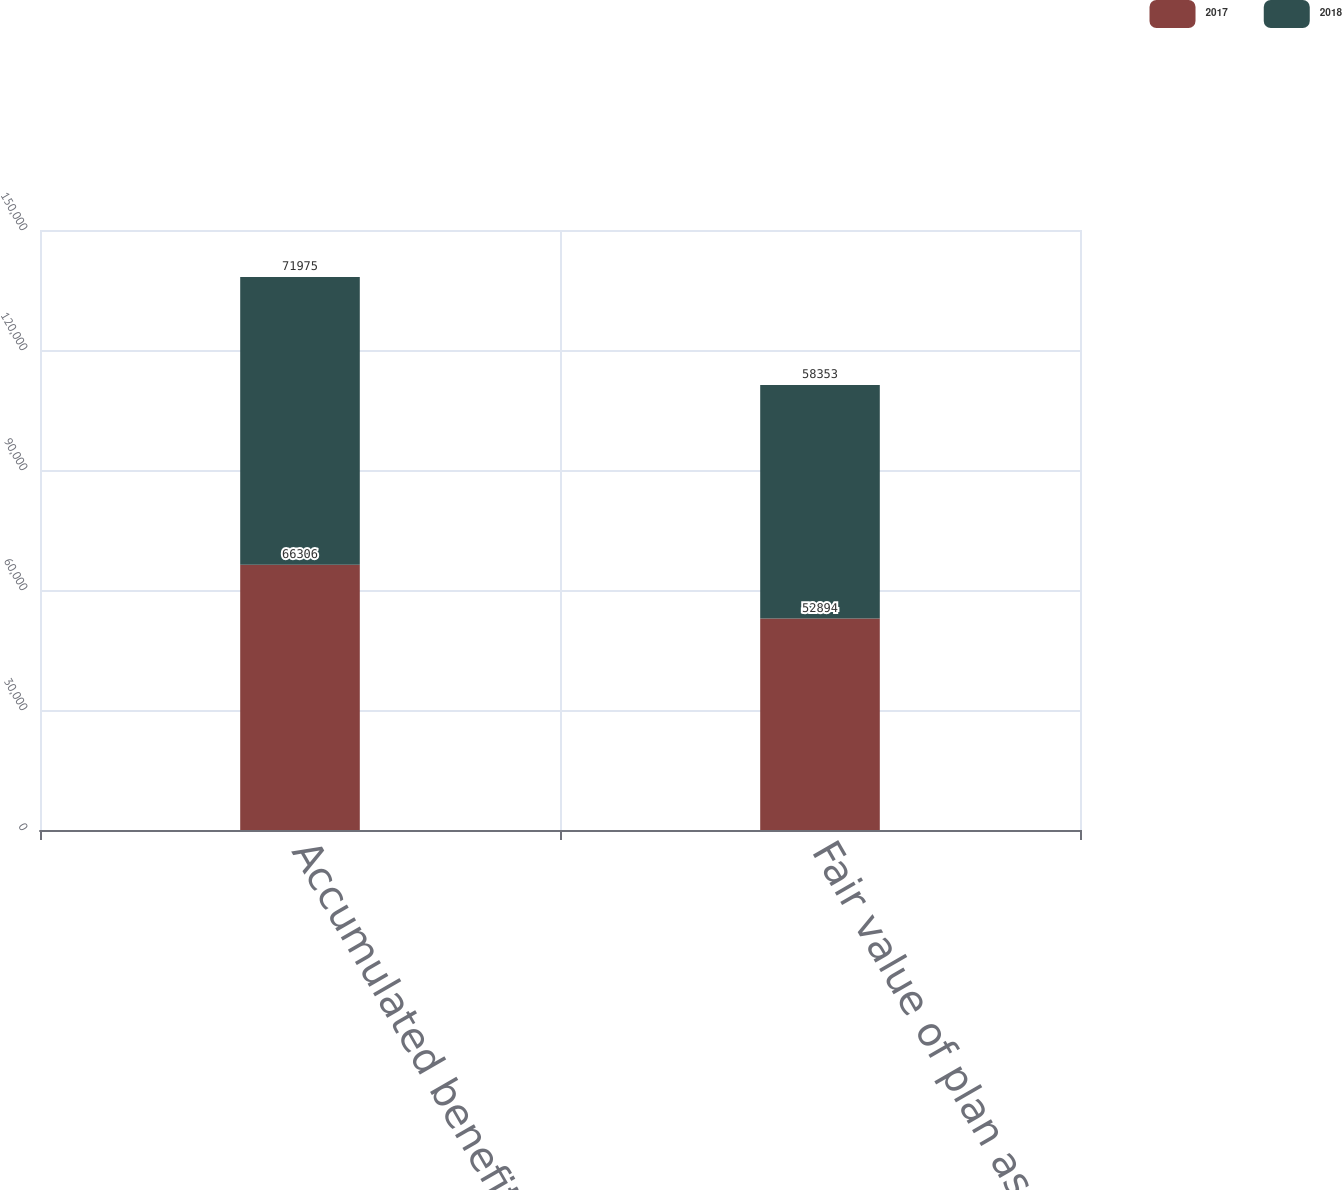Convert chart to OTSL. <chart><loc_0><loc_0><loc_500><loc_500><stacked_bar_chart><ecel><fcel>Accumulated benefit obligation<fcel>Fair value of plan assets<nl><fcel>2017<fcel>66306<fcel>52894<nl><fcel>2018<fcel>71975<fcel>58353<nl></chart> 